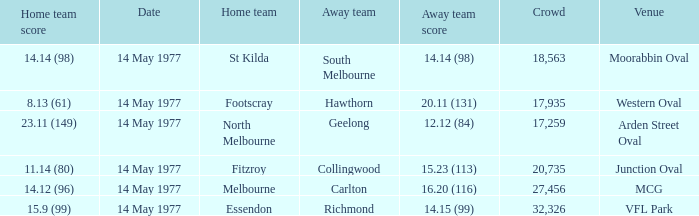How many people were in the crowd with the away team being collingwood? 1.0. 